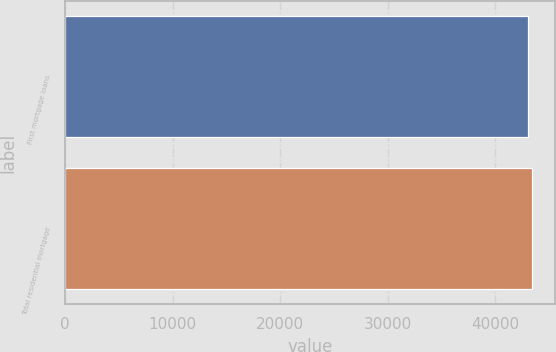<chart> <loc_0><loc_0><loc_500><loc_500><bar_chart><fcel>First mortgage loans<fcel>Total residential mortgage<nl><fcel>43004<fcel>43376<nl></chart> 